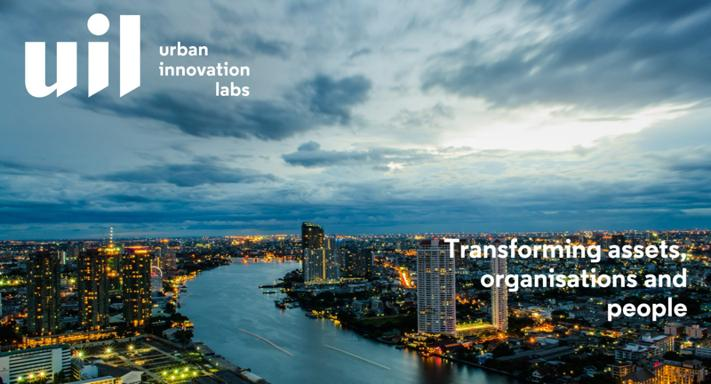How does the modern architecture in the image reflect the principles of urban innovation? The modern architecture depicted in the image exemplifies urban innovation through its energy-efficient building designs and integration into a cohesive urban landscape, which not only optimizes the use of space but also enhances the aesthetic and functional aspects of the city. 